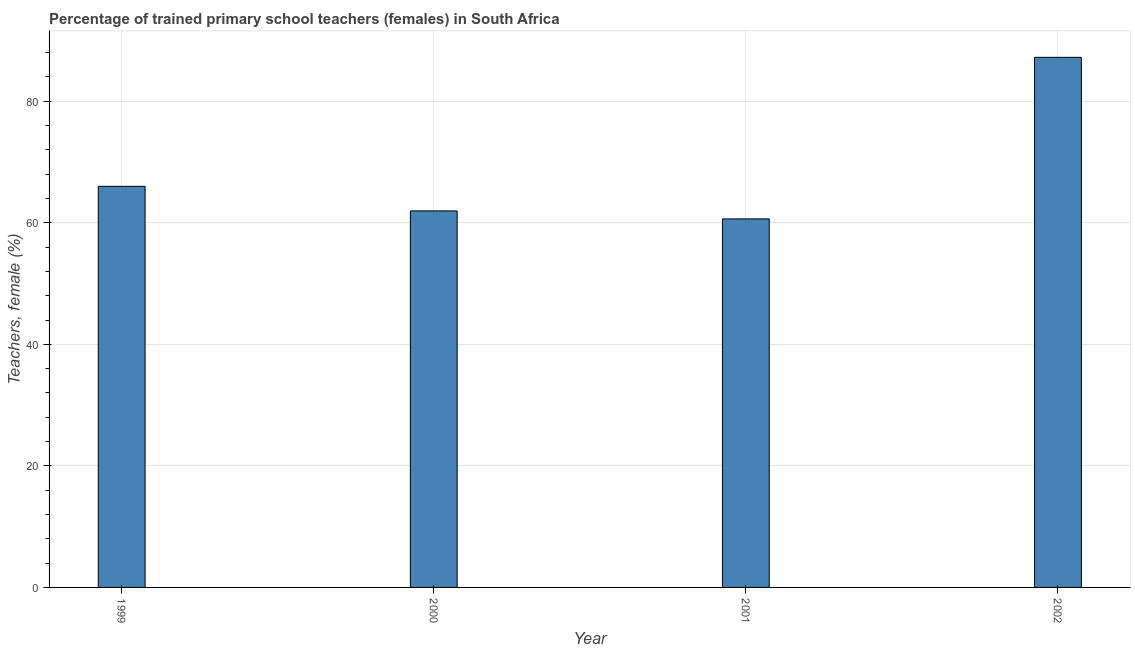Does the graph contain any zero values?
Make the answer very short. No. What is the title of the graph?
Your answer should be compact. Percentage of trained primary school teachers (females) in South Africa. What is the label or title of the Y-axis?
Provide a succinct answer. Teachers, female (%). What is the percentage of trained female teachers in 2001?
Provide a short and direct response. 60.64. Across all years, what is the maximum percentage of trained female teachers?
Make the answer very short. 87.23. Across all years, what is the minimum percentage of trained female teachers?
Ensure brevity in your answer.  60.64. In which year was the percentage of trained female teachers minimum?
Ensure brevity in your answer.  2001. What is the sum of the percentage of trained female teachers?
Your answer should be very brief. 275.83. What is the difference between the percentage of trained female teachers in 2000 and 2001?
Give a very brief answer. 1.32. What is the average percentage of trained female teachers per year?
Give a very brief answer. 68.96. What is the median percentage of trained female teachers?
Your answer should be very brief. 63.98. In how many years, is the percentage of trained female teachers greater than 64 %?
Provide a short and direct response. 2. Do a majority of the years between 2002 and 2001 (inclusive) have percentage of trained female teachers greater than 84 %?
Provide a short and direct response. No. What is the ratio of the percentage of trained female teachers in 2000 to that in 2002?
Make the answer very short. 0.71. Is the percentage of trained female teachers in 1999 less than that in 2002?
Provide a short and direct response. Yes. Is the difference between the percentage of trained female teachers in 1999 and 2002 greater than the difference between any two years?
Your answer should be compact. No. What is the difference between the highest and the second highest percentage of trained female teachers?
Your answer should be very brief. 21.23. What is the difference between the highest and the lowest percentage of trained female teachers?
Give a very brief answer. 26.59. How many years are there in the graph?
Give a very brief answer. 4. What is the Teachers, female (%) in 1999?
Keep it short and to the point. 66. What is the Teachers, female (%) of 2000?
Give a very brief answer. 61.96. What is the Teachers, female (%) in 2001?
Provide a succinct answer. 60.64. What is the Teachers, female (%) of 2002?
Your answer should be compact. 87.23. What is the difference between the Teachers, female (%) in 1999 and 2000?
Provide a succinct answer. 4.04. What is the difference between the Teachers, female (%) in 1999 and 2001?
Your response must be concise. 5.36. What is the difference between the Teachers, female (%) in 1999 and 2002?
Offer a very short reply. -21.23. What is the difference between the Teachers, female (%) in 2000 and 2001?
Offer a very short reply. 1.32. What is the difference between the Teachers, female (%) in 2000 and 2002?
Your answer should be compact. -25.27. What is the difference between the Teachers, female (%) in 2001 and 2002?
Keep it short and to the point. -26.59. What is the ratio of the Teachers, female (%) in 1999 to that in 2000?
Provide a succinct answer. 1.06. What is the ratio of the Teachers, female (%) in 1999 to that in 2001?
Offer a very short reply. 1.09. What is the ratio of the Teachers, female (%) in 1999 to that in 2002?
Keep it short and to the point. 0.76. What is the ratio of the Teachers, female (%) in 2000 to that in 2002?
Offer a very short reply. 0.71. What is the ratio of the Teachers, female (%) in 2001 to that in 2002?
Offer a terse response. 0.69. 